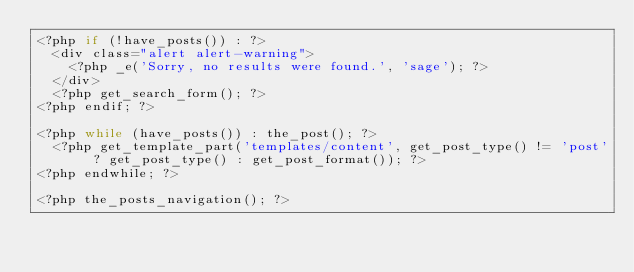Convert code to text. <code><loc_0><loc_0><loc_500><loc_500><_PHP_><?php if (!have_posts()) : ?>
  <div class="alert alert-warning">
    <?php _e('Sorry, no results were found.', 'sage'); ?>
  </div>
  <?php get_search_form(); ?>
<?php endif; ?>

<?php while (have_posts()) : the_post(); ?>
  <?php get_template_part('templates/content', get_post_type() != 'post' ? get_post_type() : get_post_format()); ?>
<?php endwhile; ?>

<?php the_posts_navigation(); ?>
</code> 